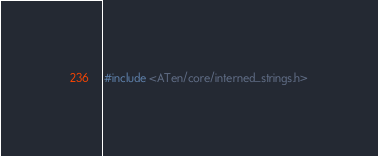Convert code to text. <code><loc_0><loc_0><loc_500><loc_500><_C++_>#include <ATen/core/interned_strings.h></code> 